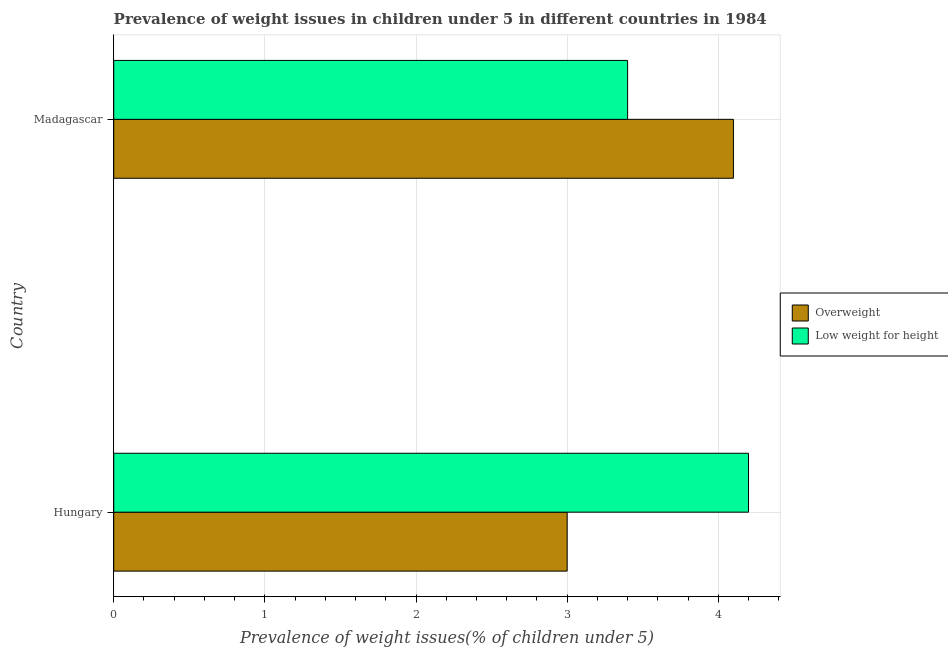How many different coloured bars are there?
Provide a succinct answer. 2. How many groups of bars are there?
Offer a terse response. 2. Are the number of bars on each tick of the Y-axis equal?
Your answer should be very brief. Yes. How many bars are there on the 2nd tick from the top?
Offer a very short reply. 2. How many bars are there on the 2nd tick from the bottom?
Provide a succinct answer. 2. What is the label of the 1st group of bars from the top?
Your answer should be very brief. Madagascar. In how many cases, is the number of bars for a given country not equal to the number of legend labels?
Provide a short and direct response. 0. What is the percentage of overweight children in Madagascar?
Ensure brevity in your answer.  4.1. Across all countries, what is the maximum percentage of underweight children?
Ensure brevity in your answer.  4.2. Across all countries, what is the minimum percentage of underweight children?
Provide a short and direct response. 3.4. In which country was the percentage of overweight children maximum?
Provide a succinct answer. Madagascar. In which country was the percentage of overweight children minimum?
Your answer should be compact. Hungary. What is the total percentage of overweight children in the graph?
Your answer should be very brief. 7.1. What is the difference between the percentage of underweight children in Hungary and the percentage of overweight children in Madagascar?
Provide a succinct answer. 0.1. What is the average percentage of underweight children per country?
Offer a terse response. 3.8. In how many countries, is the percentage of overweight children greater than 1.2 %?
Ensure brevity in your answer.  2. What is the ratio of the percentage of overweight children in Hungary to that in Madagascar?
Give a very brief answer. 0.73. Is the difference between the percentage of overweight children in Hungary and Madagascar greater than the difference between the percentage of underweight children in Hungary and Madagascar?
Offer a terse response. No. What does the 2nd bar from the top in Madagascar represents?
Ensure brevity in your answer.  Overweight. What does the 1st bar from the bottom in Madagascar represents?
Give a very brief answer. Overweight. Are all the bars in the graph horizontal?
Offer a very short reply. Yes. What is the difference between two consecutive major ticks on the X-axis?
Your response must be concise. 1. Does the graph contain any zero values?
Ensure brevity in your answer.  No. How many legend labels are there?
Keep it short and to the point. 2. How are the legend labels stacked?
Your response must be concise. Vertical. What is the title of the graph?
Keep it short and to the point. Prevalence of weight issues in children under 5 in different countries in 1984. What is the label or title of the X-axis?
Make the answer very short. Prevalence of weight issues(% of children under 5). What is the Prevalence of weight issues(% of children under 5) in Overweight in Hungary?
Your answer should be compact. 3. What is the Prevalence of weight issues(% of children under 5) in Low weight for height in Hungary?
Your response must be concise. 4.2. What is the Prevalence of weight issues(% of children under 5) of Overweight in Madagascar?
Offer a terse response. 4.1. What is the Prevalence of weight issues(% of children under 5) of Low weight for height in Madagascar?
Ensure brevity in your answer.  3.4. Across all countries, what is the maximum Prevalence of weight issues(% of children under 5) of Overweight?
Your answer should be very brief. 4.1. Across all countries, what is the maximum Prevalence of weight issues(% of children under 5) of Low weight for height?
Offer a terse response. 4.2. Across all countries, what is the minimum Prevalence of weight issues(% of children under 5) of Overweight?
Provide a short and direct response. 3. Across all countries, what is the minimum Prevalence of weight issues(% of children under 5) in Low weight for height?
Your response must be concise. 3.4. What is the total Prevalence of weight issues(% of children under 5) in Low weight for height in the graph?
Keep it short and to the point. 7.6. What is the difference between the Prevalence of weight issues(% of children under 5) in Overweight in Hungary and that in Madagascar?
Your answer should be very brief. -1.1. What is the average Prevalence of weight issues(% of children under 5) of Overweight per country?
Give a very brief answer. 3.55. What is the difference between the Prevalence of weight issues(% of children under 5) in Overweight and Prevalence of weight issues(% of children under 5) in Low weight for height in Madagascar?
Provide a succinct answer. 0.7. What is the ratio of the Prevalence of weight issues(% of children under 5) of Overweight in Hungary to that in Madagascar?
Provide a short and direct response. 0.73. What is the ratio of the Prevalence of weight issues(% of children under 5) of Low weight for height in Hungary to that in Madagascar?
Ensure brevity in your answer.  1.24. What is the difference between the highest and the second highest Prevalence of weight issues(% of children under 5) in Overweight?
Make the answer very short. 1.1. What is the difference between the highest and the lowest Prevalence of weight issues(% of children under 5) of Overweight?
Provide a succinct answer. 1.1. What is the difference between the highest and the lowest Prevalence of weight issues(% of children under 5) of Low weight for height?
Provide a short and direct response. 0.8. 